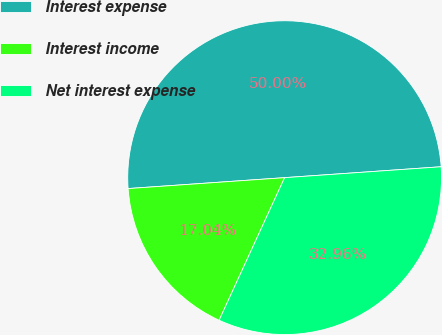Convert chart to OTSL. <chart><loc_0><loc_0><loc_500><loc_500><pie_chart><fcel>Interest expense<fcel>Interest income<fcel>Net interest expense<nl><fcel>50.0%<fcel>17.04%<fcel>32.96%<nl></chart> 